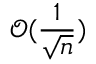<formula> <loc_0><loc_0><loc_500><loc_500>\mathcal { O } ( \frac { 1 } { \sqrt { n } } )</formula> 